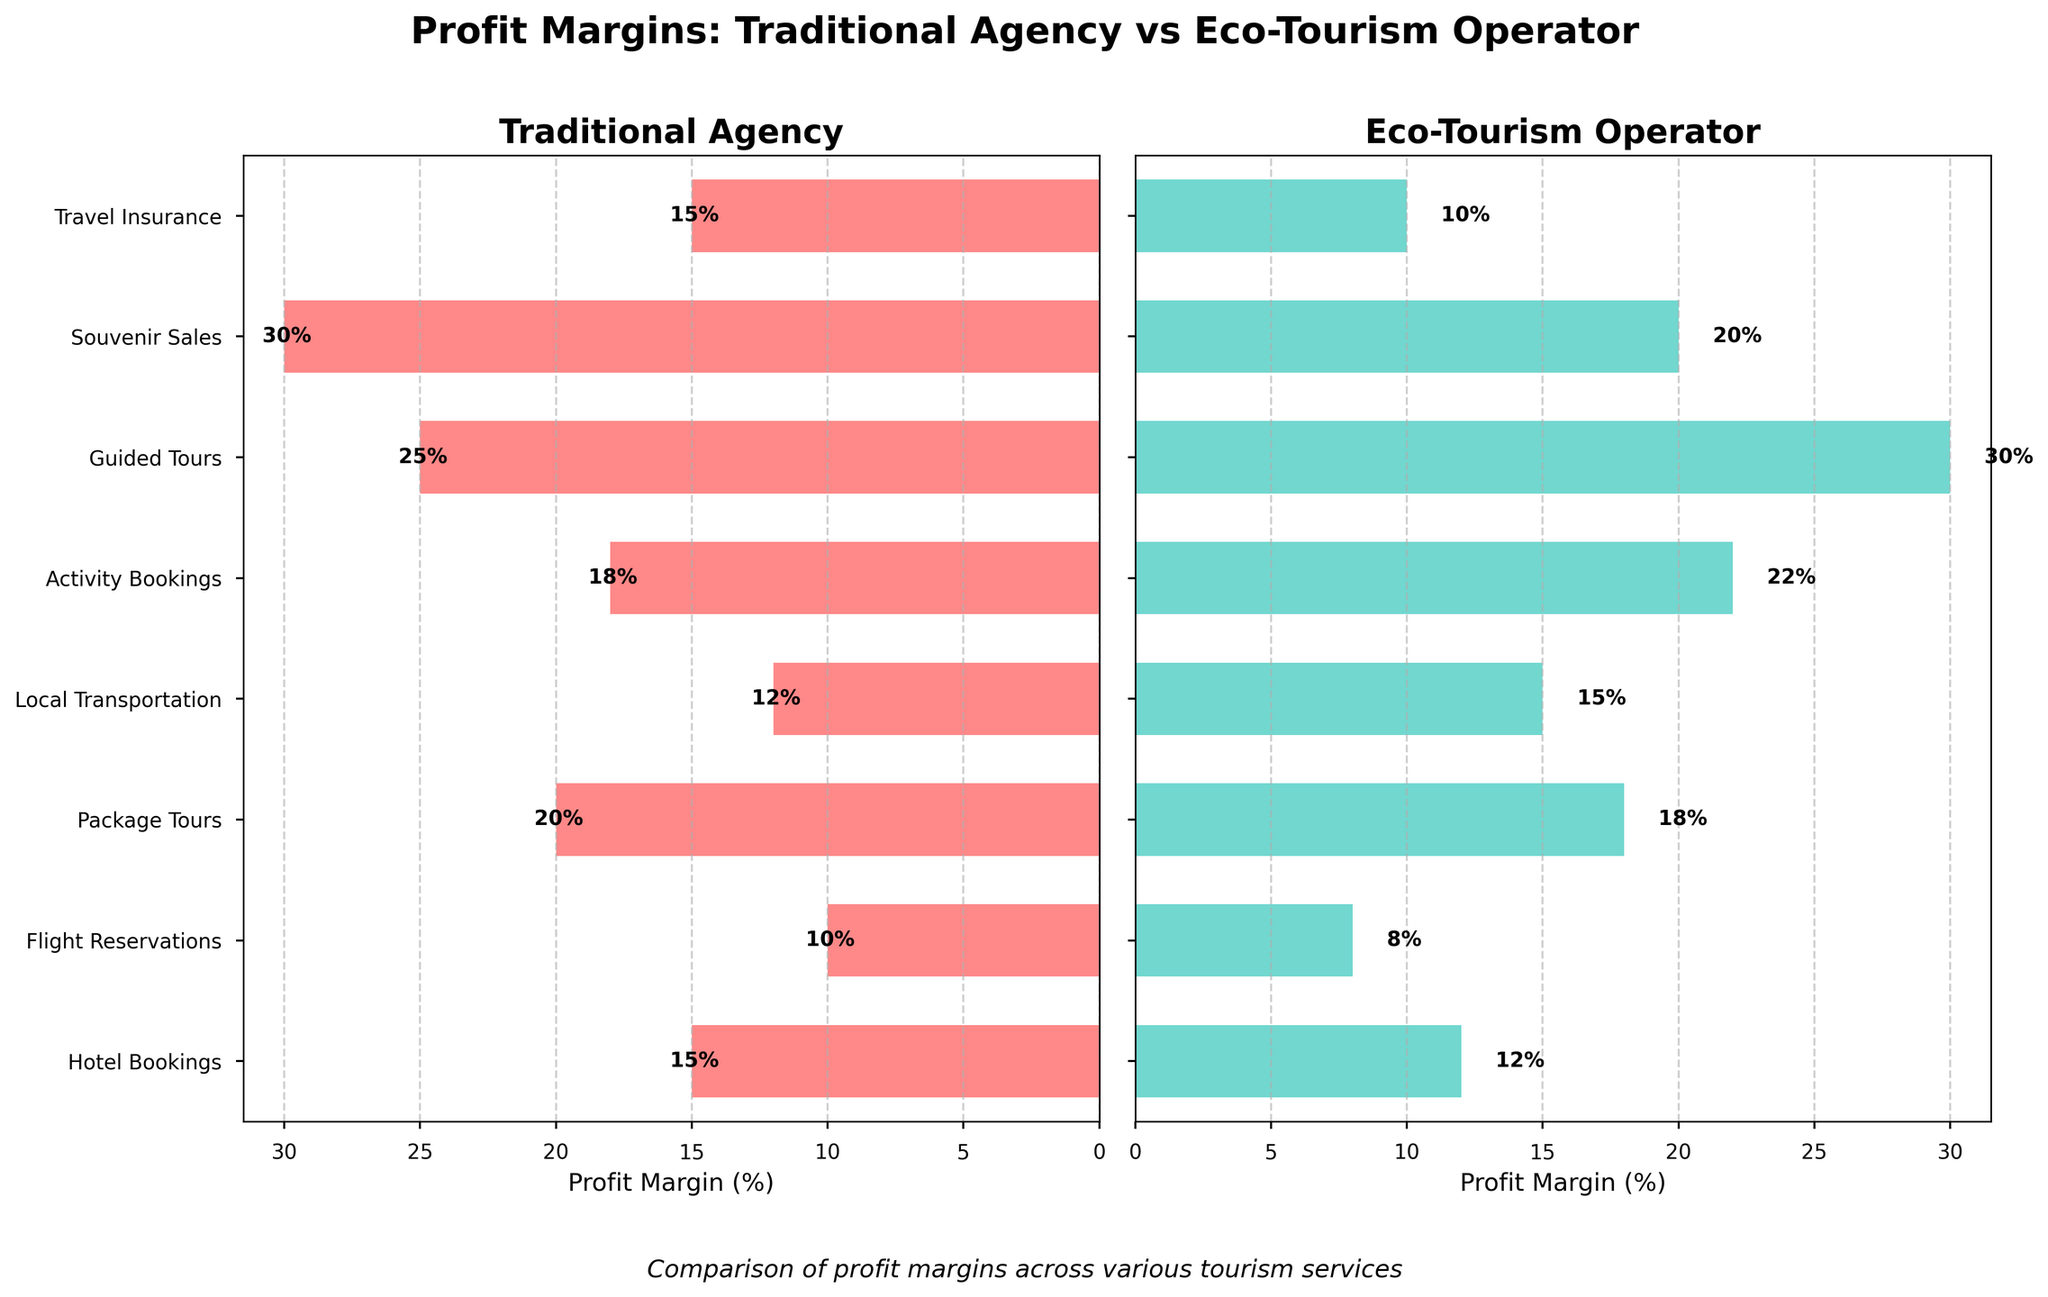What's the title of the figure? The title is prominently displayed at the top center of the figure and reads: "Profit Margins: Traditional Agency vs Eco-Tourism Operator"
Answer: Profit Margins: Traditional Agency vs Eco-Tourism Operator Which service has the highest profit margin for traditional agencies? To find this, look at the longest bar in the Traditional Agency subplot and see which service it corresponds to. The longest bar corresponds to Souvenir Sales.
Answer: Souvenir Sales What is the profit margin for Activity Bookings in eco-tourism operators? Locate the bar labeled "Activity Bookings" in the Eco-Tourism Operator subplot and read the value at the end of the bar. It shows 22%.
Answer: 22% Which type of tourism provider has a higher profit margin for Local Transportation? Compare the lengths of the bars for Local Transportation in both subplots. The eco-tourism operator has a bar with a value of 15%, which is higher than the traditional agency's 12%.
Answer: Eco-Tourism Operator What is the difference in profit margins for Guided Tours between traditional agencies and eco-tourism operators? The values for Guided Tours are 25% for traditional agencies and 30% for eco-tourism operators. Calculate the difference: 30% - 25%.
Answer: 5% How many services have higher profit margins in traditional agencies compared to eco-tourism operators? For each service, compare the bars' lengths in both subplots and count the number of services where the traditional agency's bar is longer. Services are: Hotel Bookings, Flight Reservations, Package Tours, Souvenir Sales, and Travel Insurance.
Answer: 5 Calculate the average profit margin for traditional agencies across all services. Summing up all profit margins for traditional agencies (15 + 10 + 20 + 12 + 18 + 25 + 30 + 15) gives 145%. There are 8 services, so the average is 145/8.
Answer: 18.125% Which service shows the largest difference in profit margins between traditional agencies and eco-tourism operators? Calculate the absolute difference for each service. The values are: Hotel Bookings (3), Flight Reservations (2), Package Tours (2), Local Transportation (3), Activity Bookings (4), Guided Tours (5), Souvenir Sales (10), and Travel Insurance (5). The largest difference is 10% for Souvenir Sales.
Answer: Souvenir Sales What's the smallest profit margin observed in the figure, and for which service and type of agency is it? Look at the shortest bars in both subplots. Flight Reservations in Eco-Tourism Operators shows the smallest profit margin at 8%.
Answer: 8%, Flight Reservations, Eco-Tourism Operator Which service has equal or nearly equal profit margins between traditional agencies and eco-tourism operators? Compare the bars for all services. The closest values are Package Tours: 20% for traditional agencies and 18% for eco-tourism operators.
Answer: Package Tours 